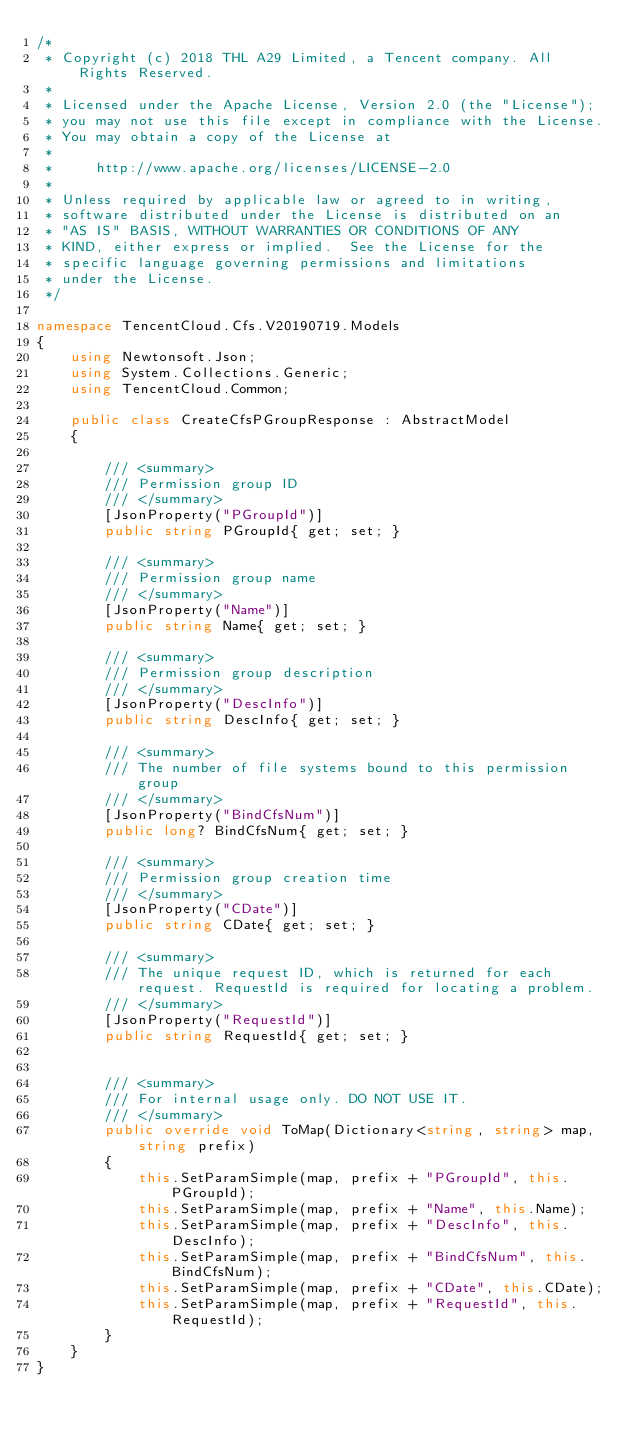<code> <loc_0><loc_0><loc_500><loc_500><_C#_>/*
 * Copyright (c) 2018 THL A29 Limited, a Tencent company. All Rights Reserved.
 *
 * Licensed under the Apache License, Version 2.0 (the "License");
 * you may not use this file except in compliance with the License.
 * You may obtain a copy of the License at
 *
 *     http://www.apache.org/licenses/LICENSE-2.0
 *
 * Unless required by applicable law or agreed to in writing,
 * software distributed under the License is distributed on an
 * "AS IS" BASIS, WITHOUT WARRANTIES OR CONDITIONS OF ANY
 * KIND, either express or implied.  See the License for the
 * specific language governing permissions and limitations
 * under the License.
 */

namespace TencentCloud.Cfs.V20190719.Models
{
    using Newtonsoft.Json;
    using System.Collections.Generic;
    using TencentCloud.Common;

    public class CreateCfsPGroupResponse : AbstractModel
    {
        
        /// <summary>
        /// Permission group ID
        /// </summary>
        [JsonProperty("PGroupId")]
        public string PGroupId{ get; set; }

        /// <summary>
        /// Permission group name
        /// </summary>
        [JsonProperty("Name")]
        public string Name{ get; set; }

        /// <summary>
        /// Permission group description
        /// </summary>
        [JsonProperty("DescInfo")]
        public string DescInfo{ get; set; }

        /// <summary>
        /// The number of file systems bound to this permission group
        /// </summary>
        [JsonProperty("BindCfsNum")]
        public long? BindCfsNum{ get; set; }

        /// <summary>
        /// Permission group creation time
        /// </summary>
        [JsonProperty("CDate")]
        public string CDate{ get; set; }

        /// <summary>
        /// The unique request ID, which is returned for each request. RequestId is required for locating a problem.
        /// </summary>
        [JsonProperty("RequestId")]
        public string RequestId{ get; set; }


        /// <summary>
        /// For internal usage only. DO NOT USE IT.
        /// </summary>
        public override void ToMap(Dictionary<string, string> map, string prefix)
        {
            this.SetParamSimple(map, prefix + "PGroupId", this.PGroupId);
            this.SetParamSimple(map, prefix + "Name", this.Name);
            this.SetParamSimple(map, prefix + "DescInfo", this.DescInfo);
            this.SetParamSimple(map, prefix + "BindCfsNum", this.BindCfsNum);
            this.SetParamSimple(map, prefix + "CDate", this.CDate);
            this.SetParamSimple(map, prefix + "RequestId", this.RequestId);
        }
    }
}

</code> 